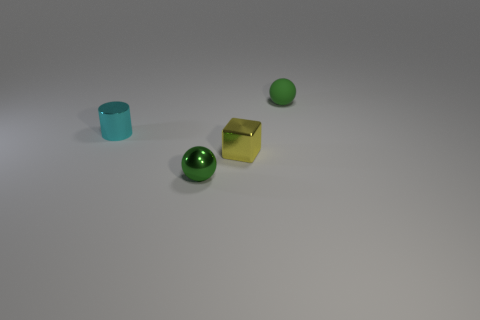Are the objects arranged in any particular pattern? The objects appear to be arranged randomly on a flat surface, without any discernible pattern. 